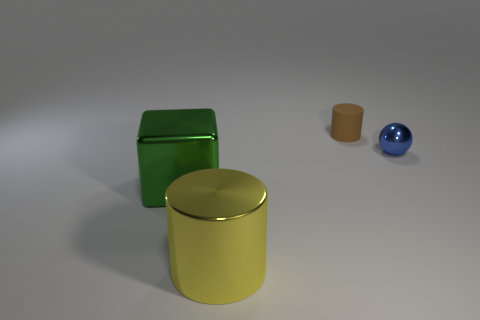What number of matte cylinders have the same color as the rubber object?
Provide a short and direct response. 0. Is the color of the shiny thing left of the large yellow metal cylinder the same as the rubber cylinder?
Keep it short and to the point. No. There is a tiny thing that is behind the small blue shiny ball; what is its shape?
Keep it short and to the point. Cylinder. Is there a big yellow object that is on the right side of the cylinder that is behind the tiny sphere?
Your answer should be very brief. No. What number of large yellow things are the same material as the small blue object?
Your answer should be compact. 1. There is a cylinder that is in front of the tiny thing in front of the cylinder that is behind the small blue metal object; what is its size?
Offer a very short reply. Large. What number of big green blocks are on the right side of the brown rubber cylinder?
Keep it short and to the point. 0. Are there more yellow cylinders than cylinders?
Ensure brevity in your answer.  No. There is a thing that is both in front of the small brown thing and behind the large cube; how big is it?
Ensure brevity in your answer.  Small. What is the material of the small thing that is to the right of the cylinder behind the large metal object on the right side of the block?
Provide a succinct answer. Metal. 